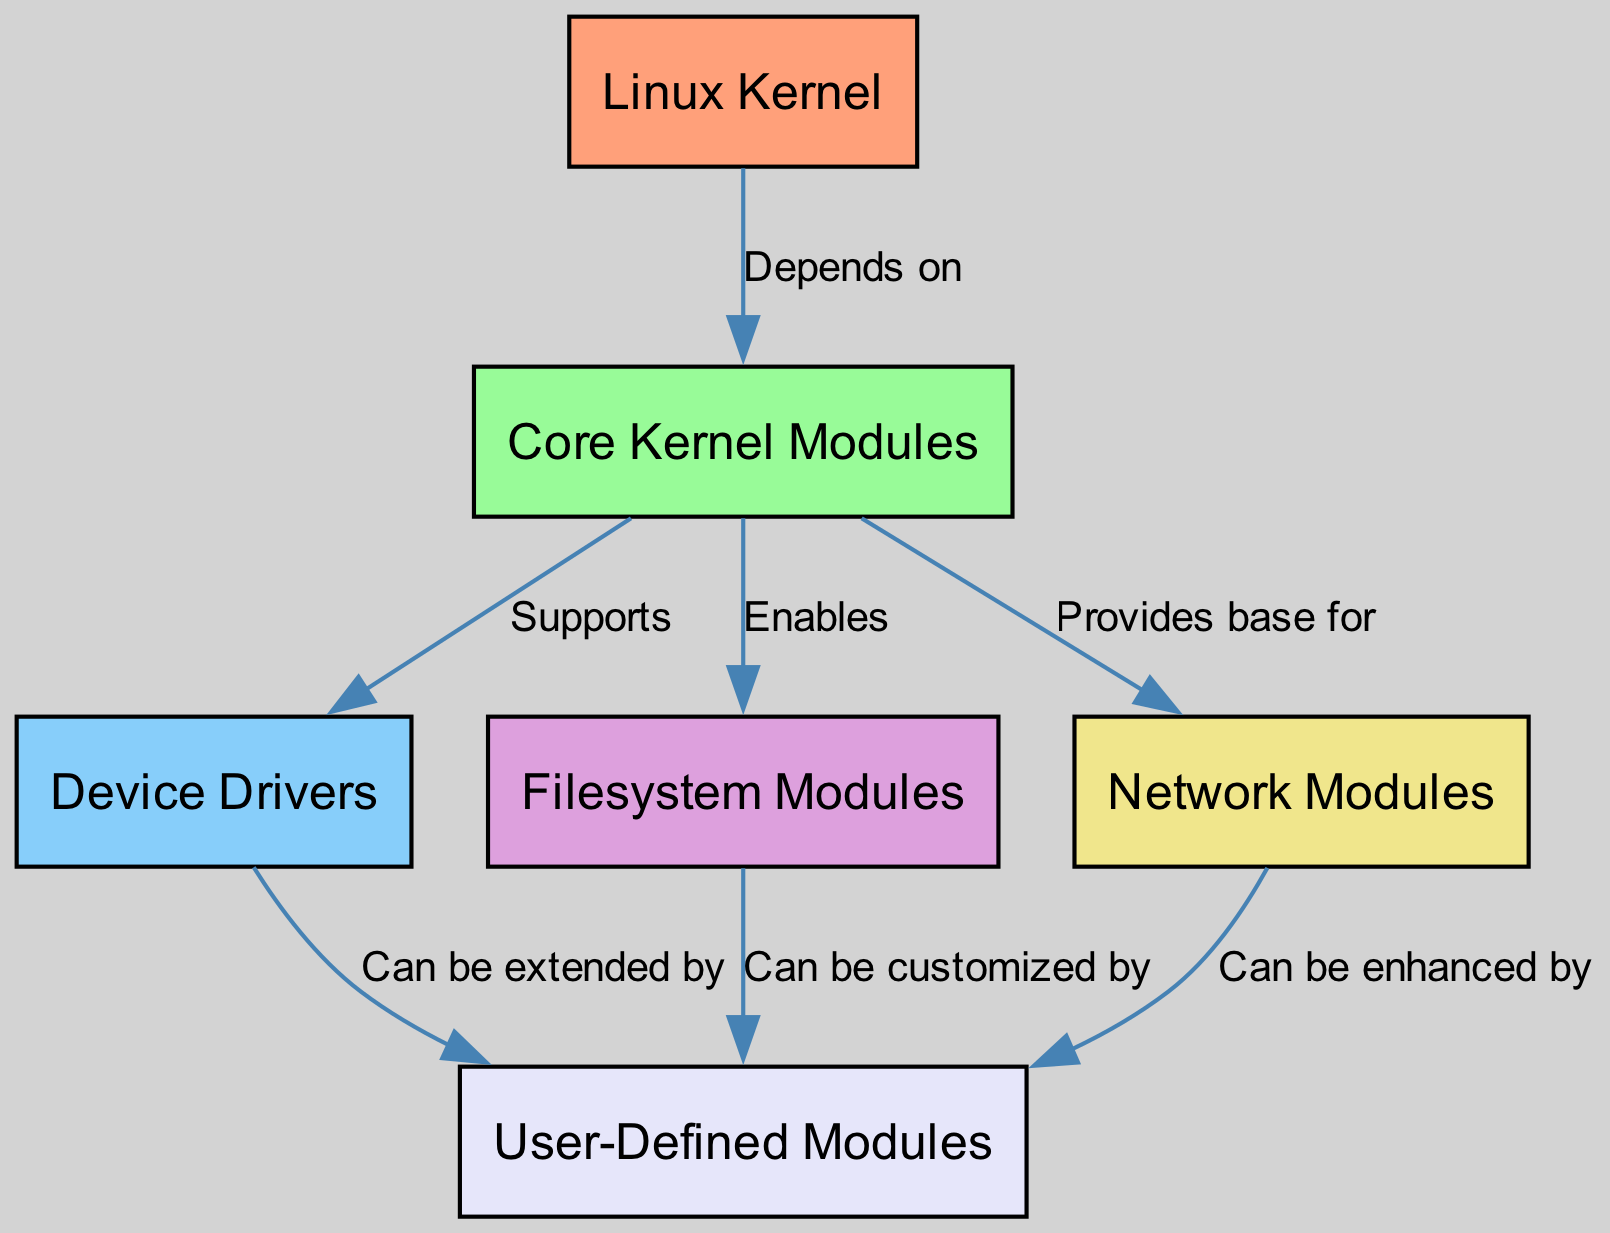What is the root node of the diagram? The root node is "Linux Kernel," which is the topmost node that all other nodes depend on. It serves as the foundation of the entire diagram, indicating that all other modules are associated with it in some capacity.
Answer: Linux Kernel How many nodes are present in the diagram? The diagram contains a total of six nodes, which include the Linux Kernel, Core Kernel Modules, Device Drivers, Filesystem Modules, Network Modules, and User-Defined Modules. By counting each distinct node, we arrive at this total.
Answer: 6 Which module does the Core Kernel Modules support? The Core Kernel Modules support the Device Drivers, as indicated by the "Supports" label connecting the Core Kernel Modules to the Device Drivers in the diagram.
Answer: Device Drivers How do Filesystem Modules interact with User-Defined Modules? Filesystem Modules interact with User-Defined Modules by allowing customization, as shown by the edge labeled "Can be customized by," connecting these two modules.
Answer: Can be customized by Which module enables the Filesystem Modules? The "Core Kernel Modules" enables the Filesystem Modules, as indicated by the edge labeled "Enables" connecting the two modules. This indicates that the Core Kernel Modules provide the functionality to utilize Filesystem Modules.
Answer: Core Kernel Modules What relationship exists between Device Drivers and User-Defined Modules? Device Drivers can be extended by User-Defined Modules, as indicated by the edge labeled "Can be extended by" linking these two modules in the diagram. This implies a dependency where User-Defined Modules enhance the functionality of Device Drivers.
Answer: Can be extended by How many types of modules can extend User-Defined Modules? Three types of modules can extend User-Defined Modules: Device Drivers, Filesystem Modules, and Network Modules, as each of these three modules is connected to User-Defined Modules with different labels indicating their relationship.
Answer: 3 What relationship connects Network Modules to User-Defined Modules? Network Modules can be enhanced by User-Defined Modules, which is indicated by the edge labeled "Can be enhanced by" that connects these two modules in the diagram. This suggests that User-Defined Modules build upon Network Modules' functionality.
Answer: Can be enhanced by What is the first dependency listed in the diagram? The first dependency listed in the diagram is between the "Linux Kernel" and "Core Kernel Modules," which indicates that the entire structure relies on Core Kernel Modules as a fundamental component.
Answer: Core Kernel Modules 